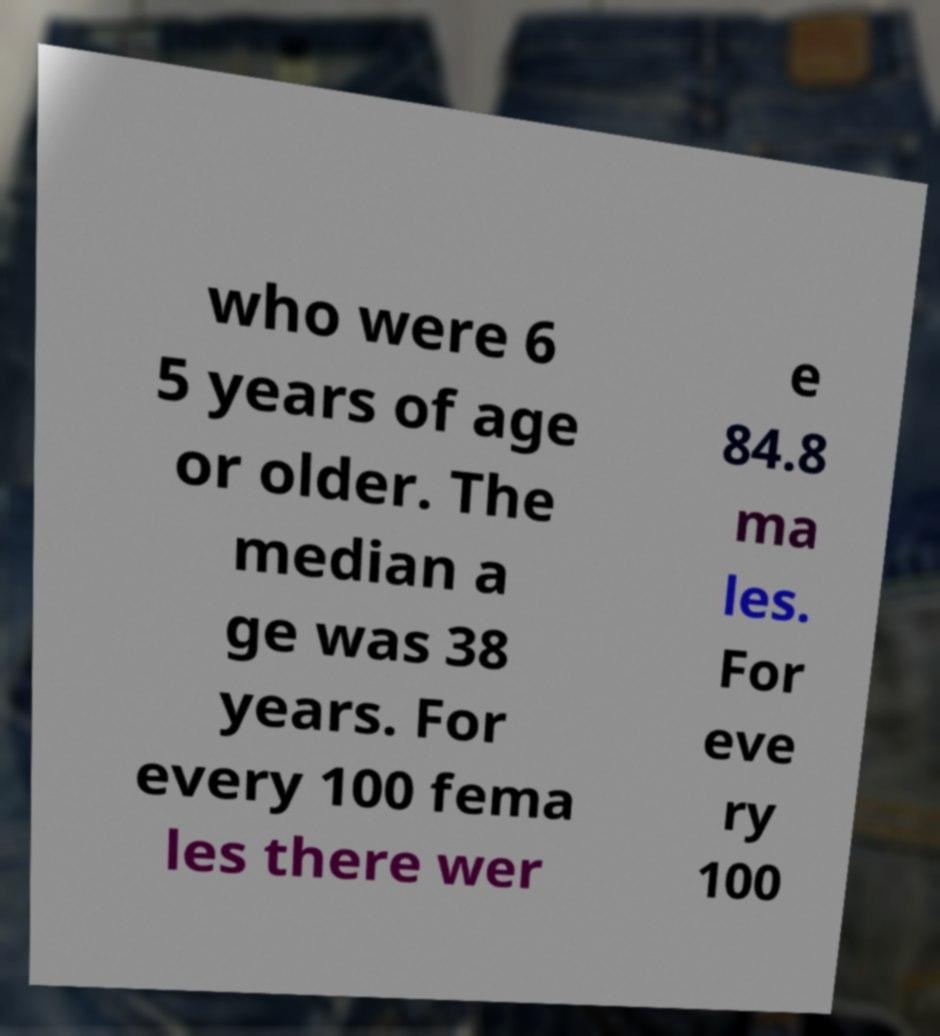What messages or text are displayed in this image? I need them in a readable, typed format. who were 6 5 years of age or older. The median a ge was 38 years. For every 100 fema les there wer e 84.8 ma les. For eve ry 100 